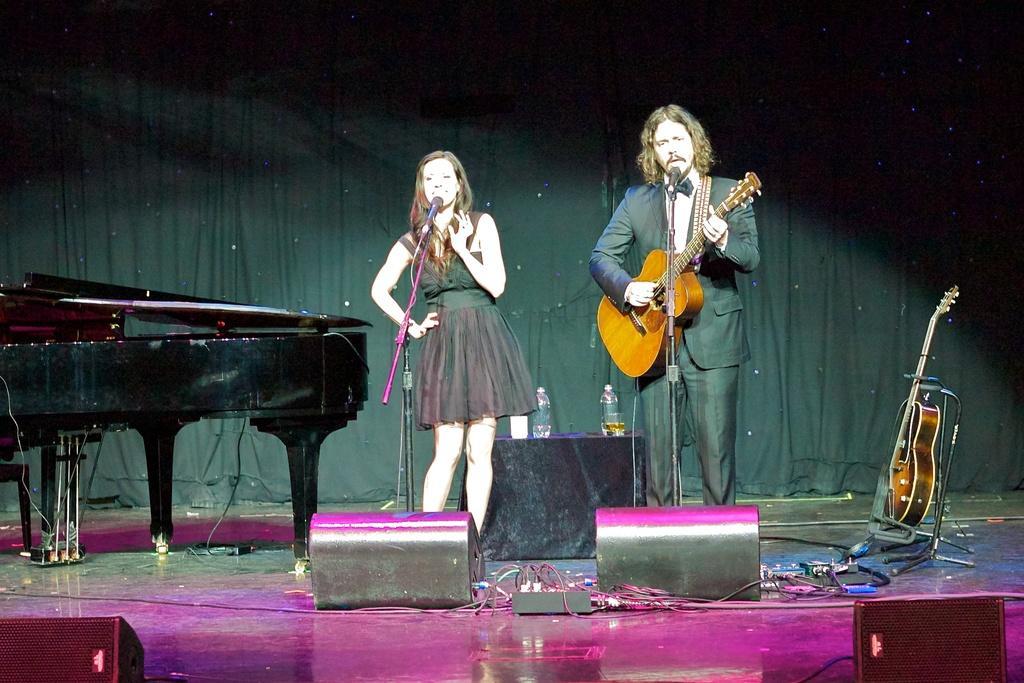In one or two sentences, can you explain what this image depicts? A lady wearing a black dress is singing. In front of her a mic and stand. A person holding guitar, playing and singing in front of a mic. There is a table. On the table there are bottles. There are speakers. There is a piano, a guitar, wires on the stage. In the background there is a curtain. 